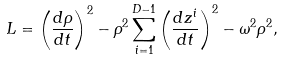<formula> <loc_0><loc_0><loc_500><loc_500>L = \left ( \frac { d \rho } { d t } \right ) ^ { 2 } - \rho ^ { 2 } \sum _ { i = 1 } ^ { D - 1 } \left ( \frac { d z ^ { i } } { d t } \right ) ^ { 2 } - \omega ^ { 2 } \rho ^ { 2 } ,</formula> 